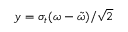<formula> <loc_0><loc_0><loc_500><loc_500>y = \sigma _ { t } ( \omega - \tilde { \omega } ) / \sqrt { 2 }</formula> 